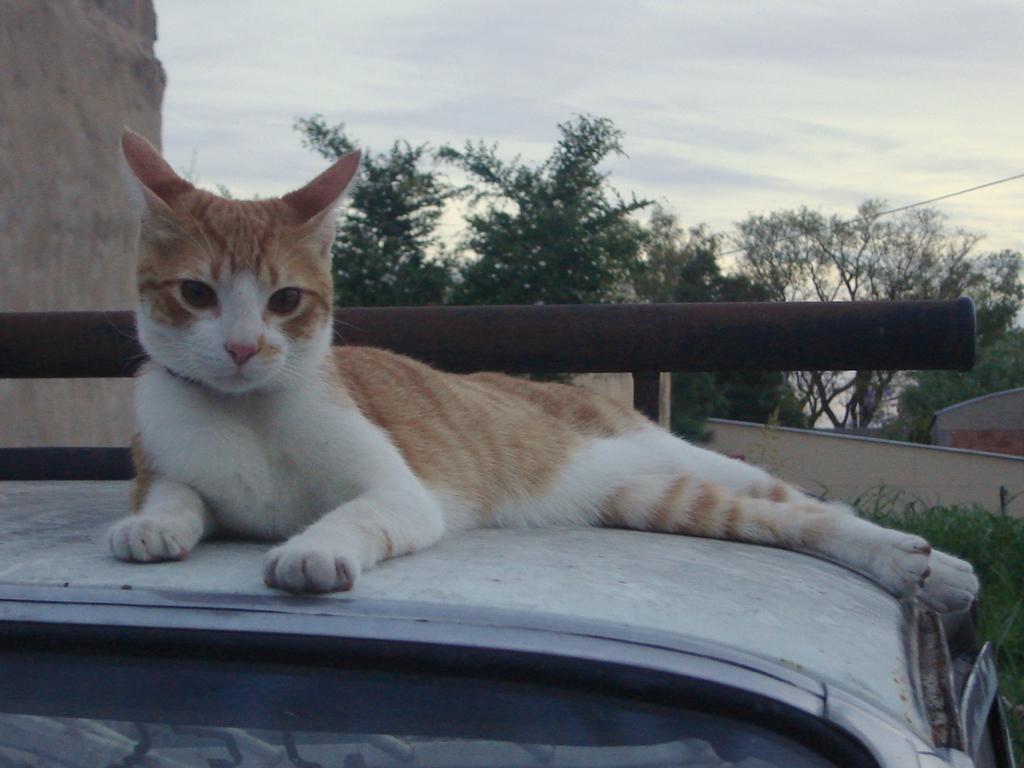Describe this image in one or two sentences. Above this vehicle there is a cat. Background we can see sky, trees, walls and rod. 